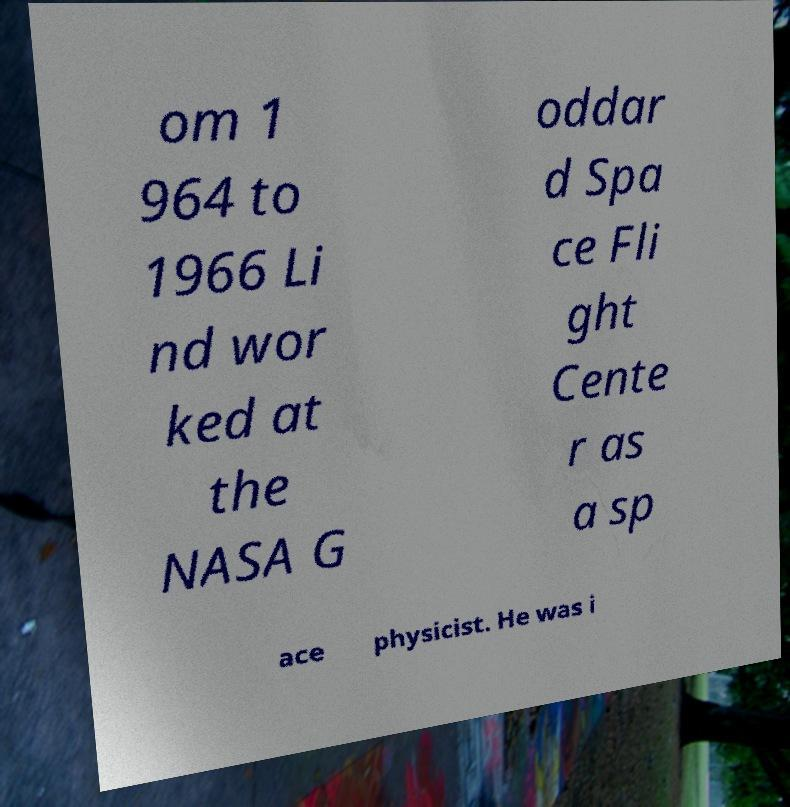I need the written content from this picture converted into text. Can you do that? om 1 964 to 1966 Li nd wor ked at the NASA G oddar d Spa ce Fli ght Cente r as a sp ace physicist. He was i 